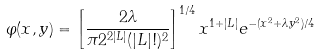<formula> <loc_0><loc_0><loc_500><loc_500>\varphi ( x , y ) = \left [ \frac { 2 \lambda } { \pi 2 ^ { 2 | L | } ( | L | ! ) ^ { 2 } } \right ] ^ { 1 / 4 } { x ^ { 1 + | L | } } e ^ { - ( x ^ { 2 } + \lambda y ^ { 2 } ) / 4 }</formula> 